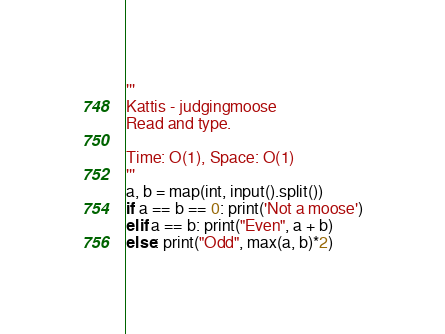Convert code to text. <code><loc_0><loc_0><loc_500><loc_500><_Python_>'''
Kattis - judgingmoose
Read and type.

Time: O(1), Space: O(1)
'''
a, b = map(int, input().split())
if a == b == 0: print('Not a moose')
elif a == b: print("Even", a + b)
else: print("Odd", max(a, b)*2)</code> 